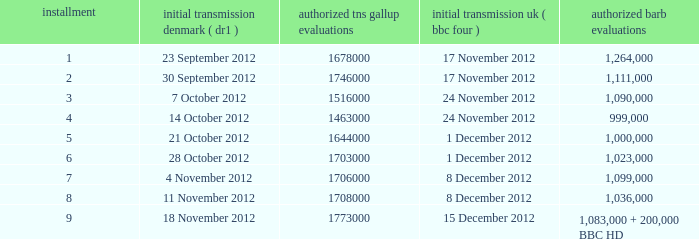Help me parse the entirety of this table. {'header': ['installment', 'initial transmission denmark ( dr1 )', 'authorized tns gallup evaluations', 'initial transmission uk ( bbc four )', 'authorized barb evaluations'], 'rows': [['1', '23 September 2012', '1678000', '17 November 2012', '1,264,000'], ['2', '30 September 2012', '1746000', '17 November 2012', '1,111,000'], ['3', '7 October 2012', '1516000', '24 November 2012', '1,090,000'], ['4', '14 October 2012', '1463000', '24 November 2012', '999,000'], ['5', '21 October 2012', '1644000', '1 December 2012', '1,000,000'], ['6', '28 October 2012', '1703000', '1 December 2012', '1,023,000'], ['7', '4 November 2012', '1706000', '8 December 2012', '1,099,000'], ['8', '11 November 2012', '1708000', '8 December 2012', '1,036,000'], ['9', '18 November 2012', '1773000', '15 December 2012', '1,083,000 + 200,000 BBC HD']]} What is the BARB ratings of episode 6? 1023000.0. 